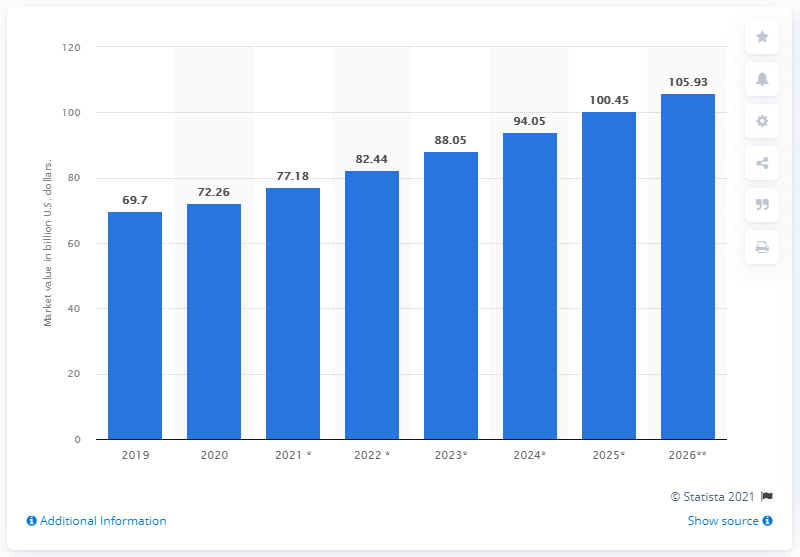Point out several critical features in this image. The global cheese market is projected to reach a value of 105.93 billion by 2026, according to a forecast. In 2020, the global cheese market was worth approximately 72.26 billion dollars. 